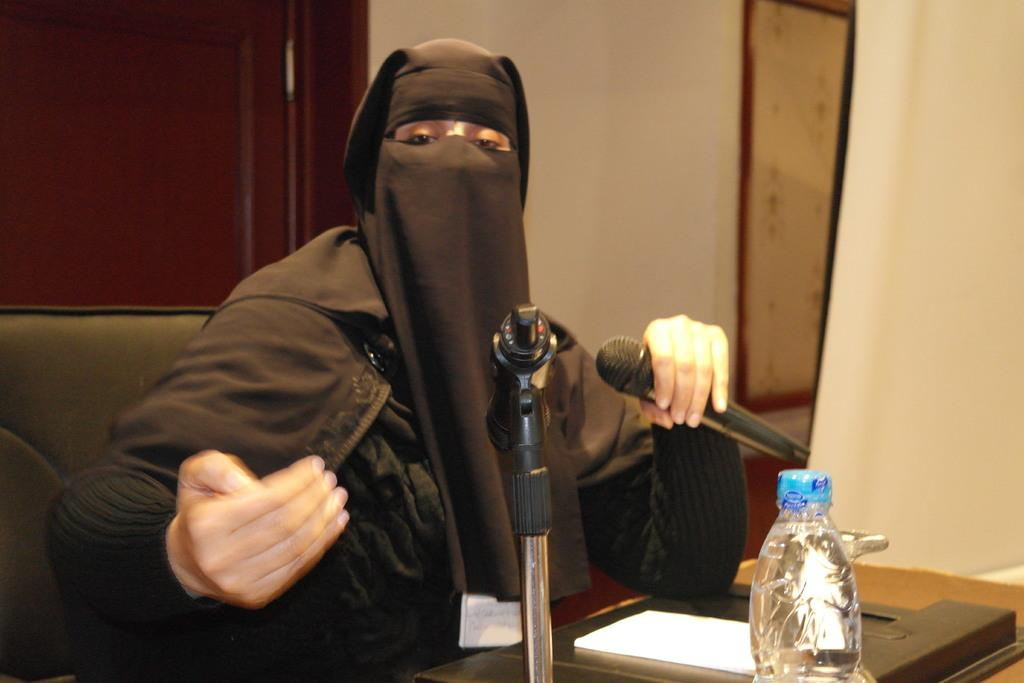Who is the main subject in the image? There is a woman in the image. What is the woman doing in the image? The woman is sitting on a sofa and speaking on a microphone. What objects can be seen on the table in the image? A file and a bottle are present on the table. What type of table is in the image? The table is made of wood. What type of game is being played on the roof in the image? There is no game or roof present in the image; it features a woman sitting on a sofa and speaking on a microphone, with a wooden table, file, and bottle nearby. 